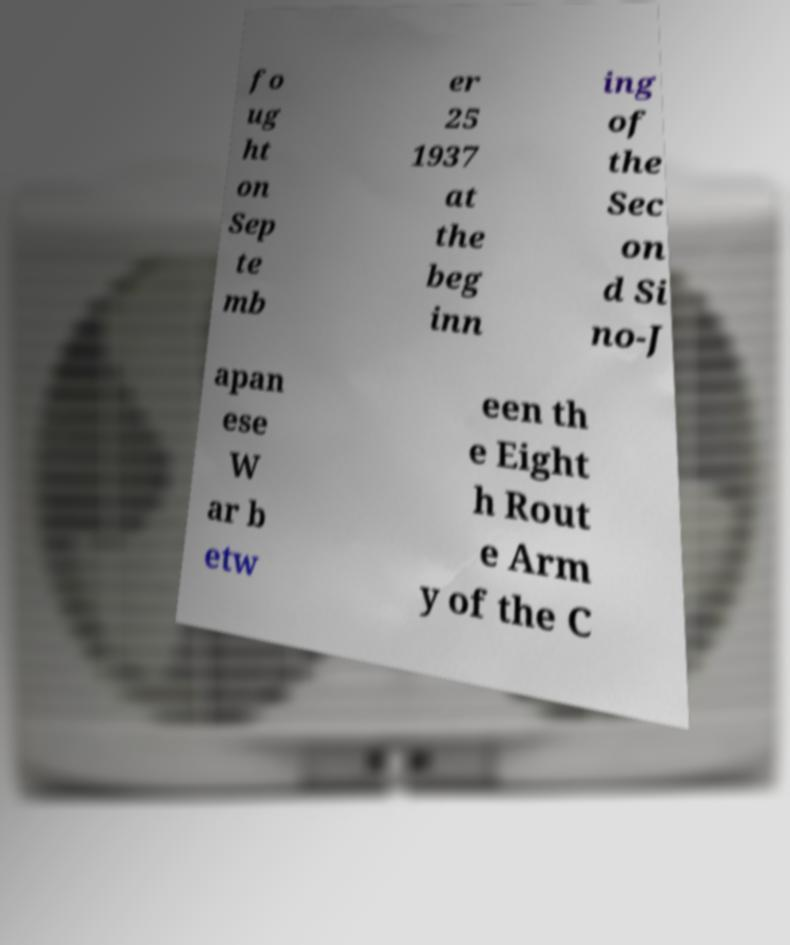Can you read and provide the text displayed in the image?This photo seems to have some interesting text. Can you extract and type it out for me? fo ug ht on Sep te mb er 25 1937 at the beg inn ing of the Sec on d Si no-J apan ese W ar b etw een th e Eight h Rout e Arm y of the C 